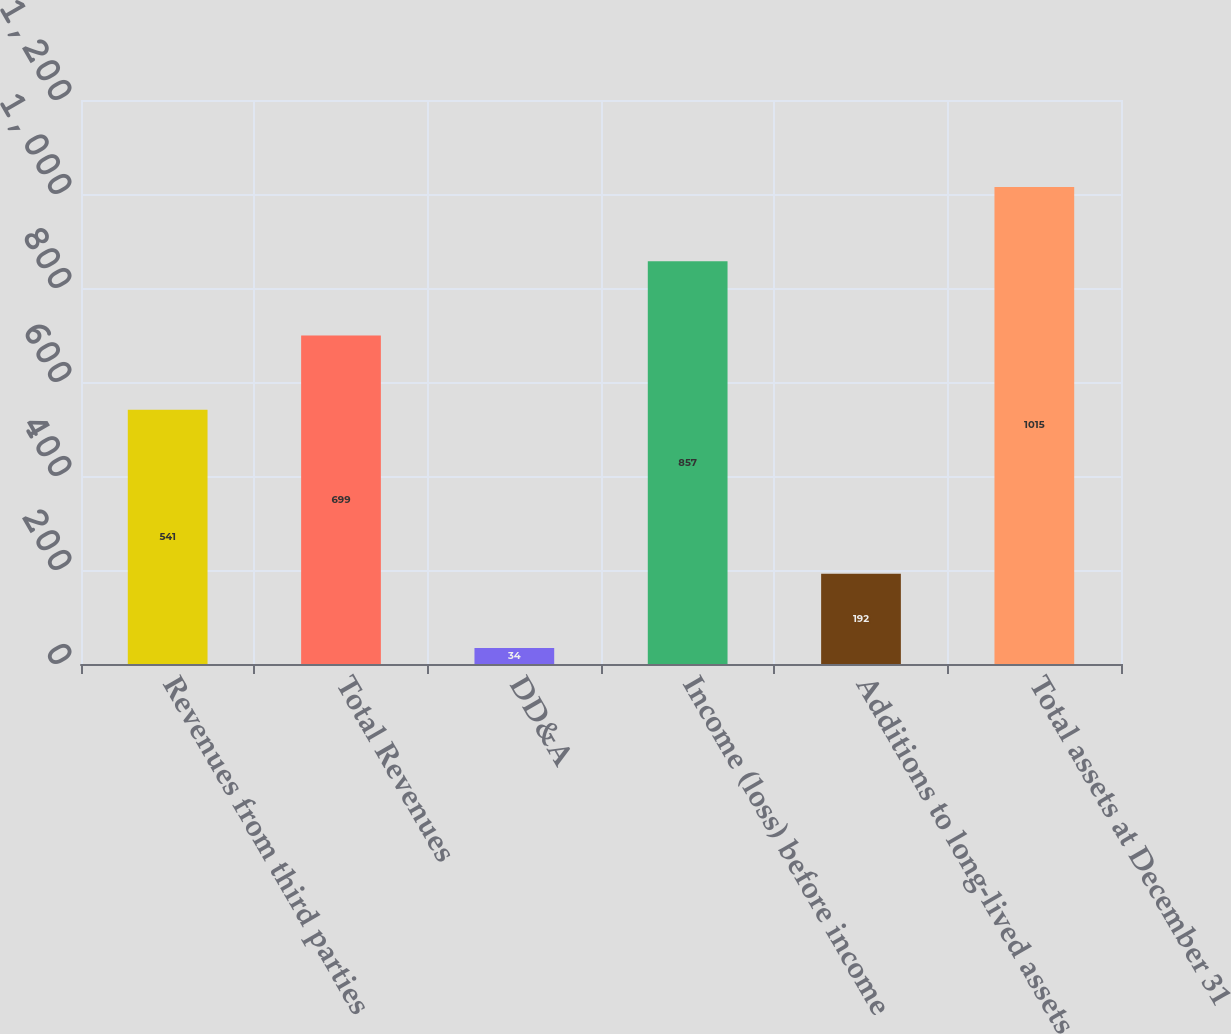Convert chart. <chart><loc_0><loc_0><loc_500><loc_500><bar_chart><fcel>Revenues from third parties<fcel>Total Revenues<fcel>DD&A<fcel>Income (loss) before income<fcel>Additions to long-lived assets<fcel>Total assets at December 31<nl><fcel>541<fcel>699<fcel>34<fcel>857<fcel>192<fcel>1015<nl></chart> 